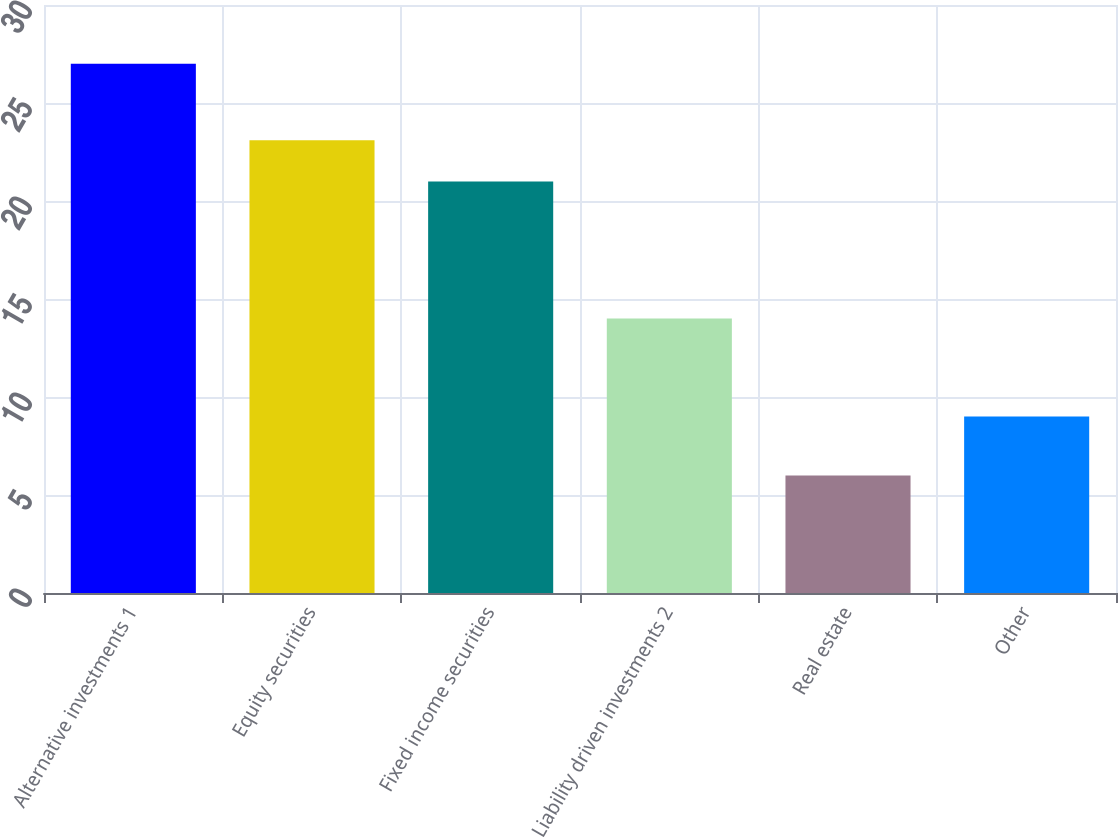Convert chart to OTSL. <chart><loc_0><loc_0><loc_500><loc_500><bar_chart><fcel>Alternative investments 1<fcel>Equity securities<fcel>Fixed income securities<fcel>Liability driven investments 2<fcel>Real estate<fcel>Other<nl><fcel>27<fcel>23.1<fcel>21<fcel>14<fcel>6<fcel>9<nl></chart> 